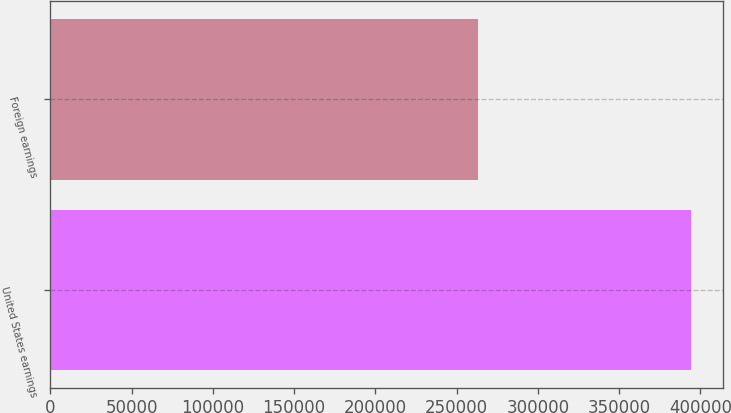<chart> <loc_0><loc_0><loc_500><loc_500><bar_chart><fcel>United States earnings<fcel>Foreign earnings<nl><fcel>394191<fcel>263220<nl></chart> 